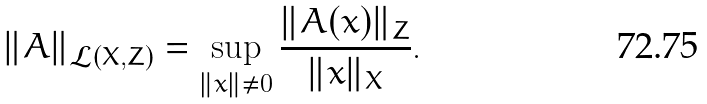Convert formula to latex. <formula><loc_0><loc_0><loc_500><loc_500>\| A \| _ { \mathcal { L } ( X , Z ) } = \sup _ { \| x \| \neq 0 } \frac { \| A ( x ) \| _ { Z } } { \| x \| _ { X } } .</formula> 